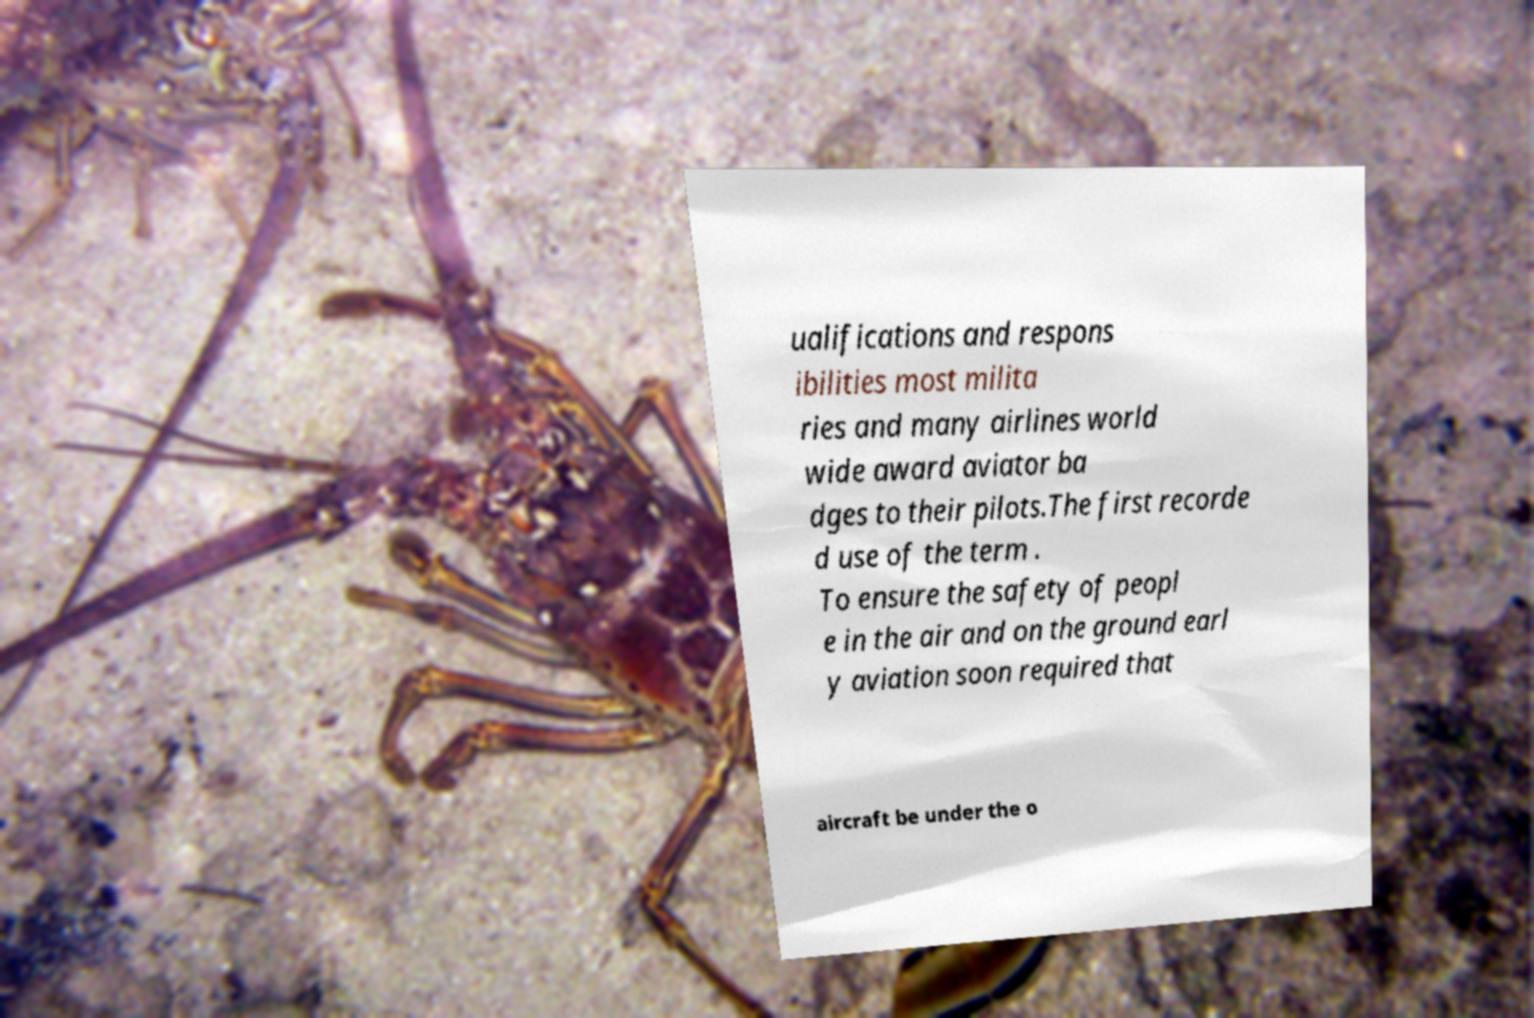For documentation purposes, I need the text within this image transcribed. Could you provide that? ualifications and respons ibilities most milita ries and many airlines world wide award aviator ba dges to their pilots.The first recorde d use of the term . To ensure the safety of peopl e in the air and on the ground earl y aviation soon required that aircraft be under the o 